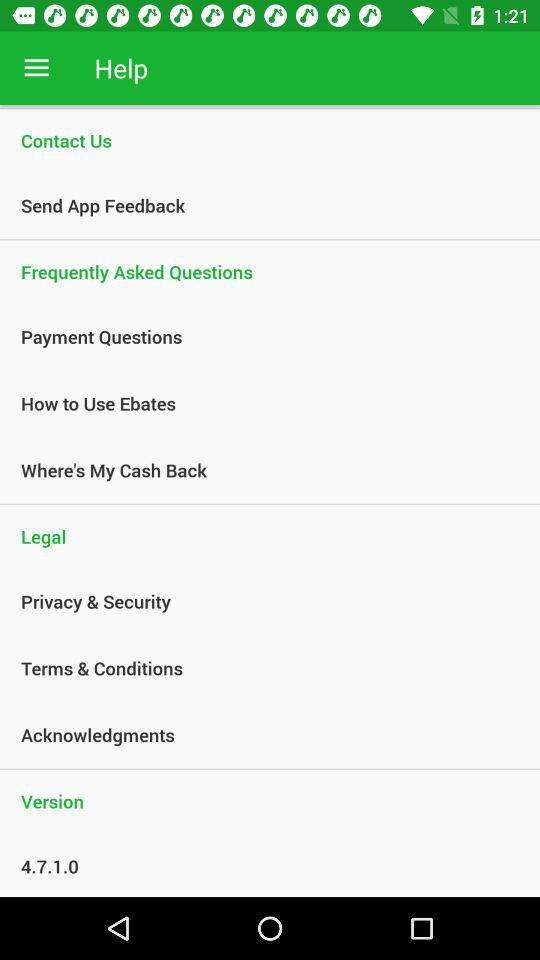What is the version? The version is 4.7.1.0. 